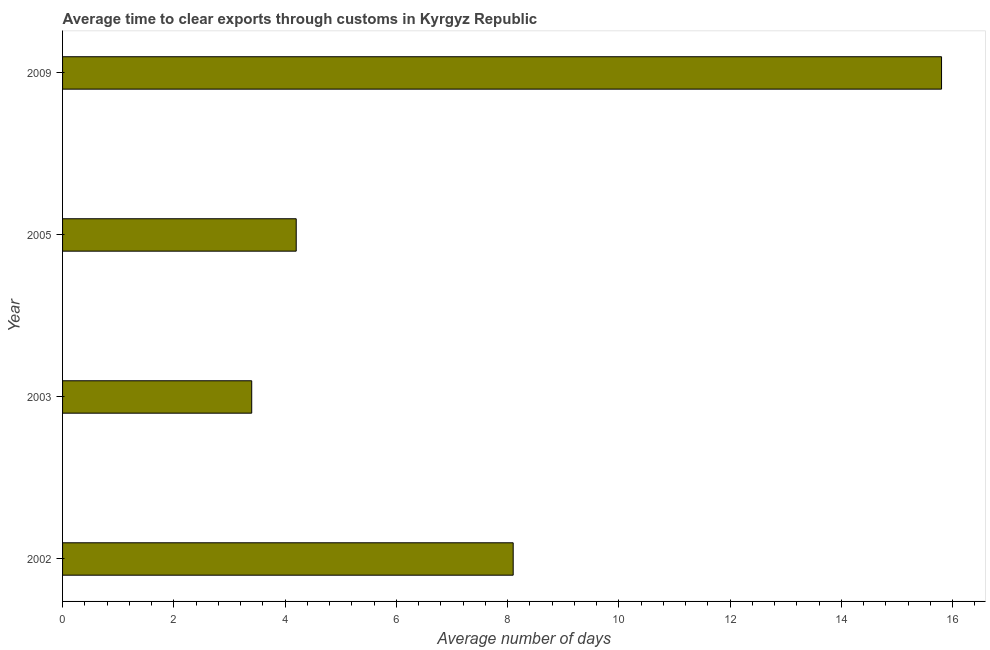Does the graph contain any zero values?
Provide a short and direct response. No. What is the title of the graph?
Offer a very short reply. Average time to clear exports through customs in Kyrgyz Republic. What is the label or title of the X-axis?
Provide a succinct answer. Average number of days. Across all years, what is the maximum time to clear exports through customs?
Your response must be concise. 15.8. In which year was the time to clear exports through customs maximum?
Provide a short and direct response. 2009. What is the sum of the time to clear exports through customs?
Your answer should be very brief. 31.5. What is the difference between the time to clear exports through customs in 2002 and 2009?
Give a very brief answer. -7.7. What is the average time to clear exports through customs per year?
Offer a terse response. 7.88. What is the median time to clear exports through customs?
Provide a short and direct response. 6.15. In how many years, is the time to clear exports through customs greater than 7.6 days?
Your answer should be very brief. 2. What is the ratio of the time to clear exports through customs in 2002 to that in 2005?
Give a very brief answer. 1.93. Is the time to clear exports through customs in 2003 less than that in 2005?
Ensure brevity in your answer.  Yes. What is the difference between the highest and the second highest time to clear exports through customs?
Offer a terse response. 7.7. Is the sum of the time to clear exports through customs in 2003 and 2009 greater than the maximum time to clear exports through customs across all years?
Offer a very short reply. Yes. What is the difference between the highest and the lowest time to clear exports through customs?
Ensure brevity in your answer.  12.4. In how many years, is the time to clear exports through customs greater than the average time to clear exports through customs taken over all years?
Provide a short and direct response. 2. How many bars are there?
Offer a terse response. 4. How many years are there in the graph?
Ensure brevity in your answer.  4. Are the values on the major ticks of X-axis written in scientific E-notation?
Give a very brief answer. No. What is the Average number of days of 2009?
Offer a very short reply. 15.8. What is the difference between the Average number of days in 2002 and 2005?
Give a very brief answer. 3.9. What is the difference between the Average number of days in 2003 and 2009?
Make the answer very short. -12.4. What is the ratio of the Average number of days in 2002 to that in 2003?
Ensure brevity in your answer.  2.38. What is the ratio of the Average number of days in 2002 to that in 2005?
Make the answer very short. 1.93. What is the ratio of the Average number of days in 2002 to that in 2009?
Offer a very short reply. 0.51. What is the ratio of the Average number of days in 2003 to that in 2005?
Ensure brevity in your answer.  0.81. What is the ratio of the Average number of days in 2003 to that in 2009?
Your answer should be compact. 0.21. What is the ratio of the Average number of days in 2005 to that in 2009?
Provide a succinct answer. 0.27. 